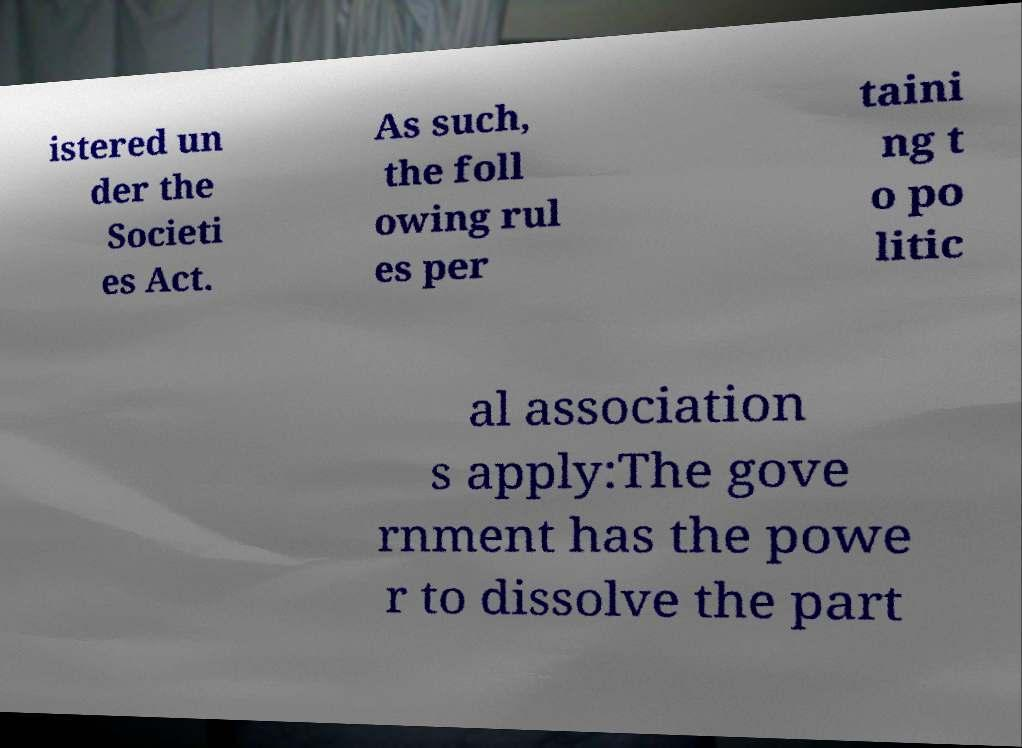Please identify and transcribe the text found in this image. istered un der the Societi es Act. As such, the foll owing rul es per taini ng t o po litic al association s apply:The gove rnment has the powe r to dissolve the part 